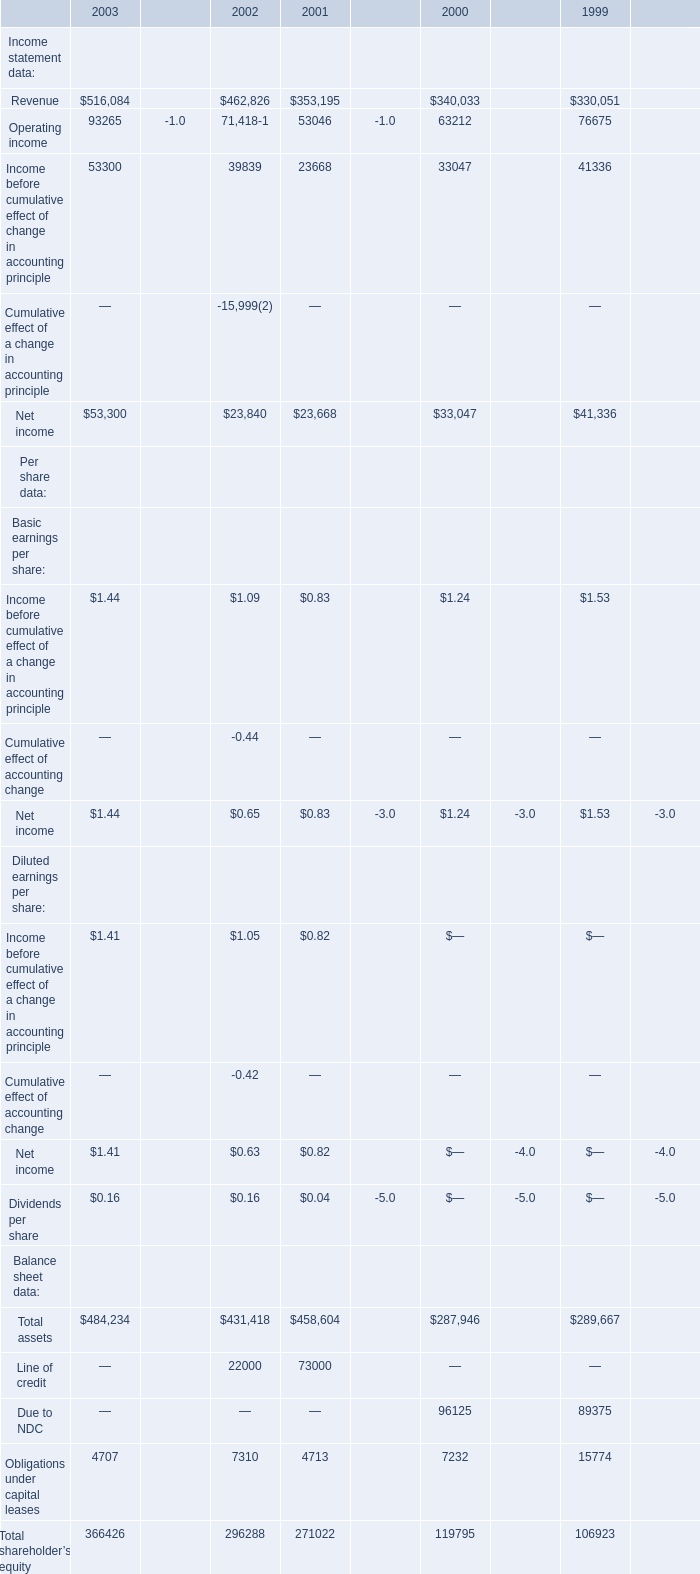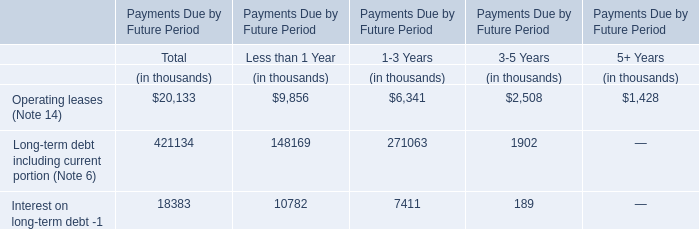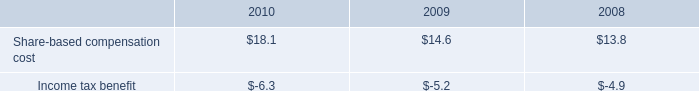What was the total amount of the Net income of Basic earnings per share in the years where Revenue greater than 400000 for Income statement data? 
Computations: (1.44 + 0.65)
Answer: 2.09. 